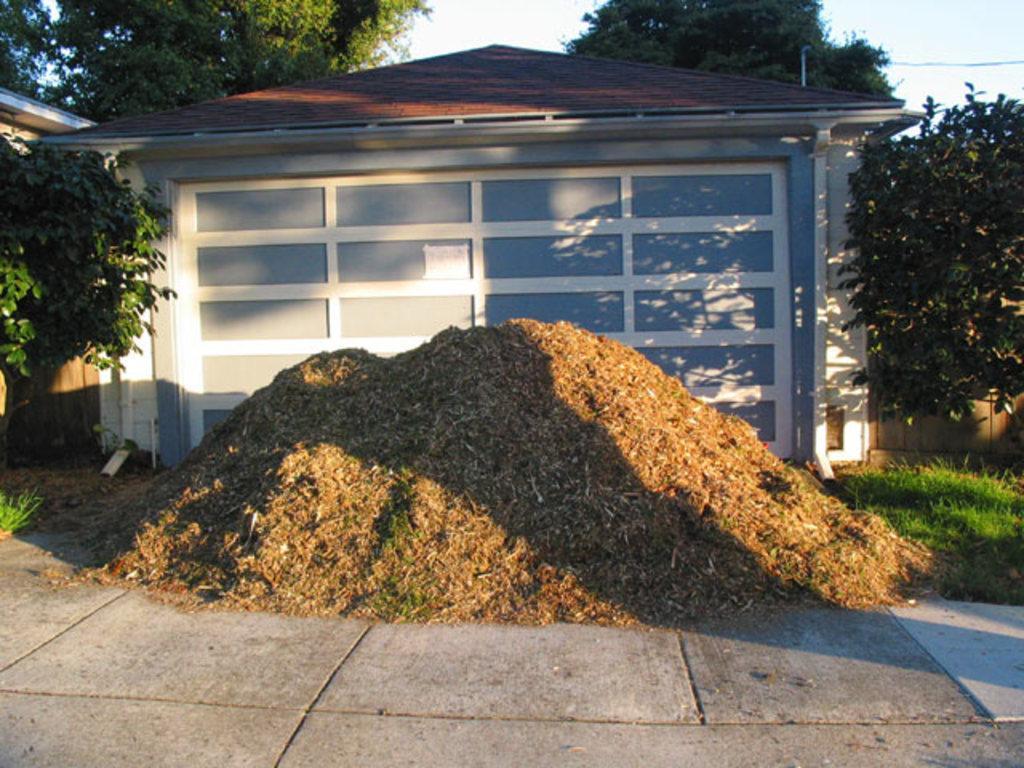In one or two sentences, can you explain what this image depicts? In this picture I can see the path in front and in the middle of this picture I can see the trees, grass, a building and the pyramid shaped thing which looks like soil. In the background I can see the sky. 